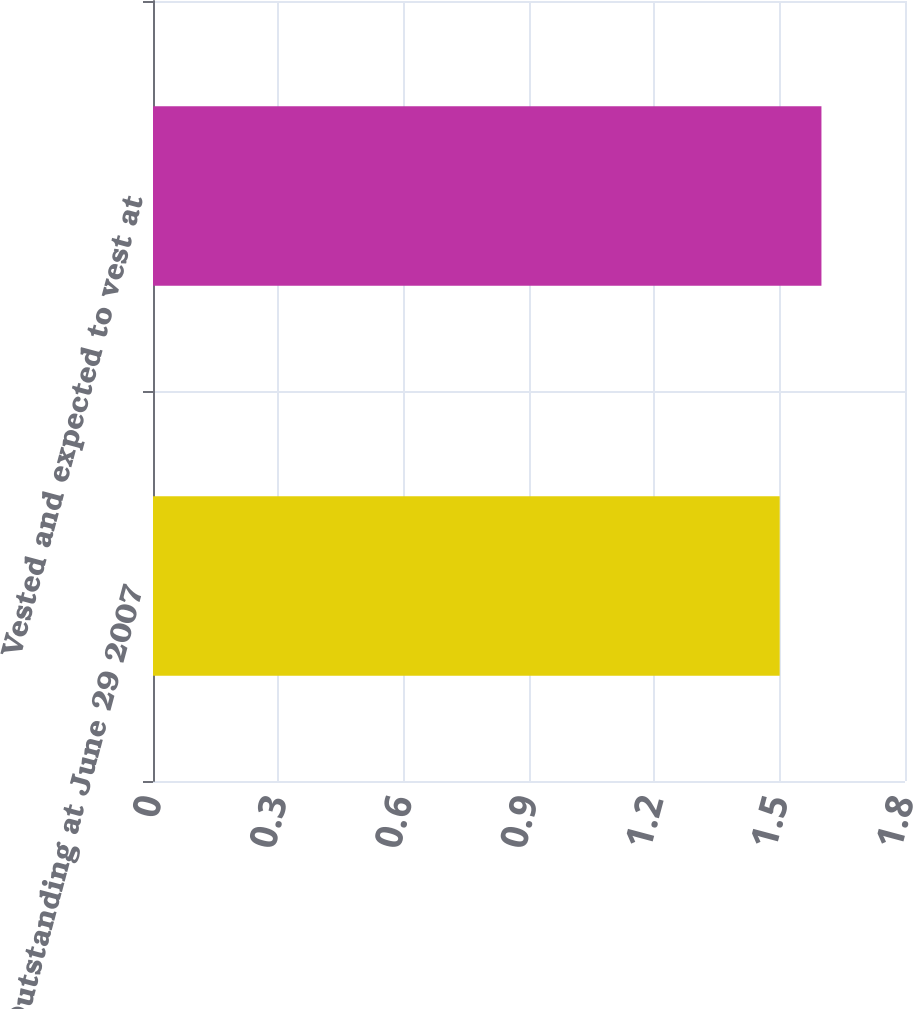<chart> <loc_0><loc_0><loc_500><loc_500><bar_chart><fcel>Outstanding at June 29 2007<fcel>Vested and expected to vest at<nl><fcel>1.5<fcel>1.6<nl></chart> 